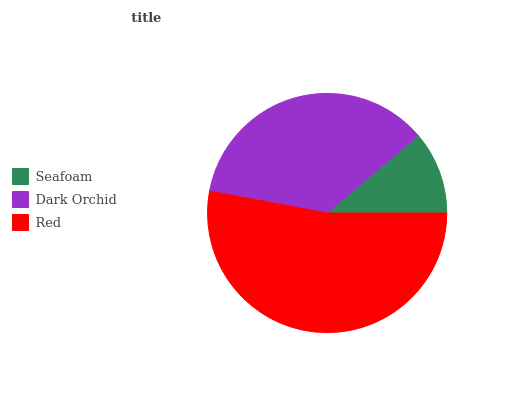Is Seafoam the minimum?
Answer yes or no. Yes. Is Red the maximum?
Answer yes or no. Yes. Is Dark Orchid the minimum?
Answer yes or no. No. Is Dark Orchid the maximum?
Answer yes or no. No. Is Dark Orchid greater than Seafoam?
Answer yes or no. Yes. Is Seafoam less than Dark Orchid?
Answer yes or no. Yes. Is Seafoam greater than Dark Orchid?
Answer yes or no. No. Is Dark Orchid less than Seafoam?
Answer yes or no. No. Is Dark Orchid the high median?
Answer yes or no. Yes. Is Dark Orchid the low median?
Answer yes or no. Yes. Is Red the high median?
Answer yes or no. No. Is Red the low median?
Answer yes or no. No. 